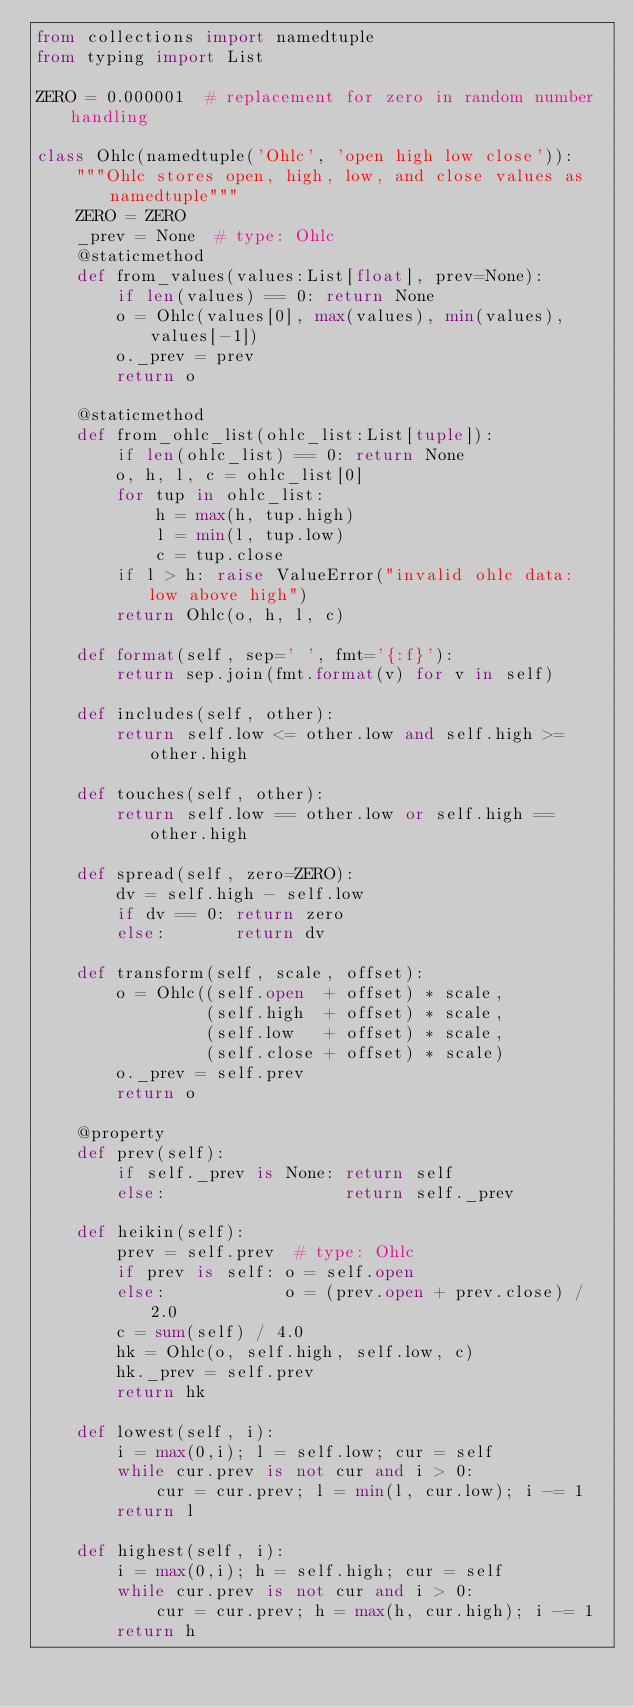Convert code to text. <code><loc_0><loc_0><loc_500><loc_500><_Python_>from collections import namedtuple
from typing import List

ZERO = 0.000001  # replacement for zero in random number handling

class Ohlc(namedtuple('Ohlc', 'open high low close')):
    """Ohlc stores open, high, low, and close values as namedtuple"""
    ZERO = ZERO
    _prev = None  # type: Ohlc
    @staticmethod
    def from_values(values:List[float], prev=None):
        if len(values) == 0: return None
        o = Ohlc(values[0], max(values), min(values), values[-1])
        o._prev = prev
        return o

    @staticmethod
    def from_ohlc_list(ohlc_list:List[tuple]):
        if len(ohlc_list) == 0: return None
        o, h, l, c = ohlc_list[0]
        for tup in ohlc_list:
            h = max(h, tup.high)
            l = min(l, tup.low)
            c = tup.close
        if l > h: raise ValueError("invalid ohlc data: low above high")
        return Ohlc(o, h, l, c)

    def format(self, sep=' ', fmt='{:f}'):
        return sep.join(fmt.format(v) for v in self)

    def includes(self, other):
        return self.low <= other.low and self.high >= other.high

    def touches(self, other):
        return self.low == other.low or self.high == other.high

    def spread(self, zero=ZERO):
        dv = self.high - self.low
        if dv == 0: return zero
        else:       return dv

    def transform(self, scale, offset):
        o = Ohlc((self.open  + offset) * scale,
                 (self.high  + offset) * scale,
                 (self.low   + offset) * scale,
                 (self.close + offset) * scale)
        o._prev = self.prev
        return o

    @property
    def prev(self):
        if self._prev is None: return self
        else:                  return self._prev

    def heikin(self):
        prev = self.prev  # type: Ohlc
        if prev is self: o = self.open
        else:            o = (prev.open + prev.close) / 2.0
        c = sum(self) / 4.0
        hk = Ohlc(o, self.high, self.low, c)
        hk._prev = self.prev
        return hk

    def lowest(self, i):
        i = max(0,i); l = self.low; cur = self
        while cur.prev is not cur and i > 0:
            cur = cur.prev; l = min(l, cur.low); i -= 1
        return l

    def highest(self, i):
        i = max(0,i); h = self.high; cur = self
        while cur.prev is not cur and i > 0:
            cur = cur.prev; h = max(h, cur.high); i -= 1
        return h

</code> 